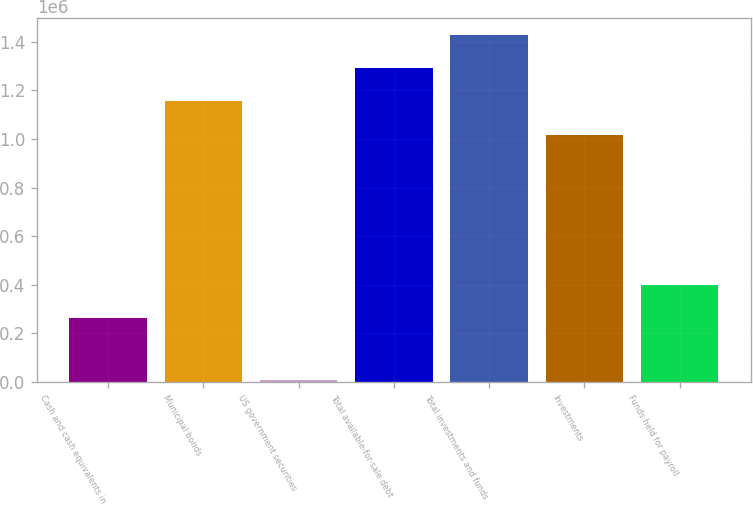Convert chart. <chart><loc_0><loc_0><loc_500><loc_500><bar_chart><fcel>Cash and cash equivalents in<fcel>Municipal bonds<fcel>US government securities<fcel>Total available-for-sale debt<fcel>Total investments and funds<fcel>Investments<fcel>Funds held for payroll<nl><fcel>263279<fcel>1.1541e+06<fcel>9900<fcel>1.2906e+06<fcel>1.4271e+06<fcel>1.0176e+06<fcel>399779<nl></chart> 